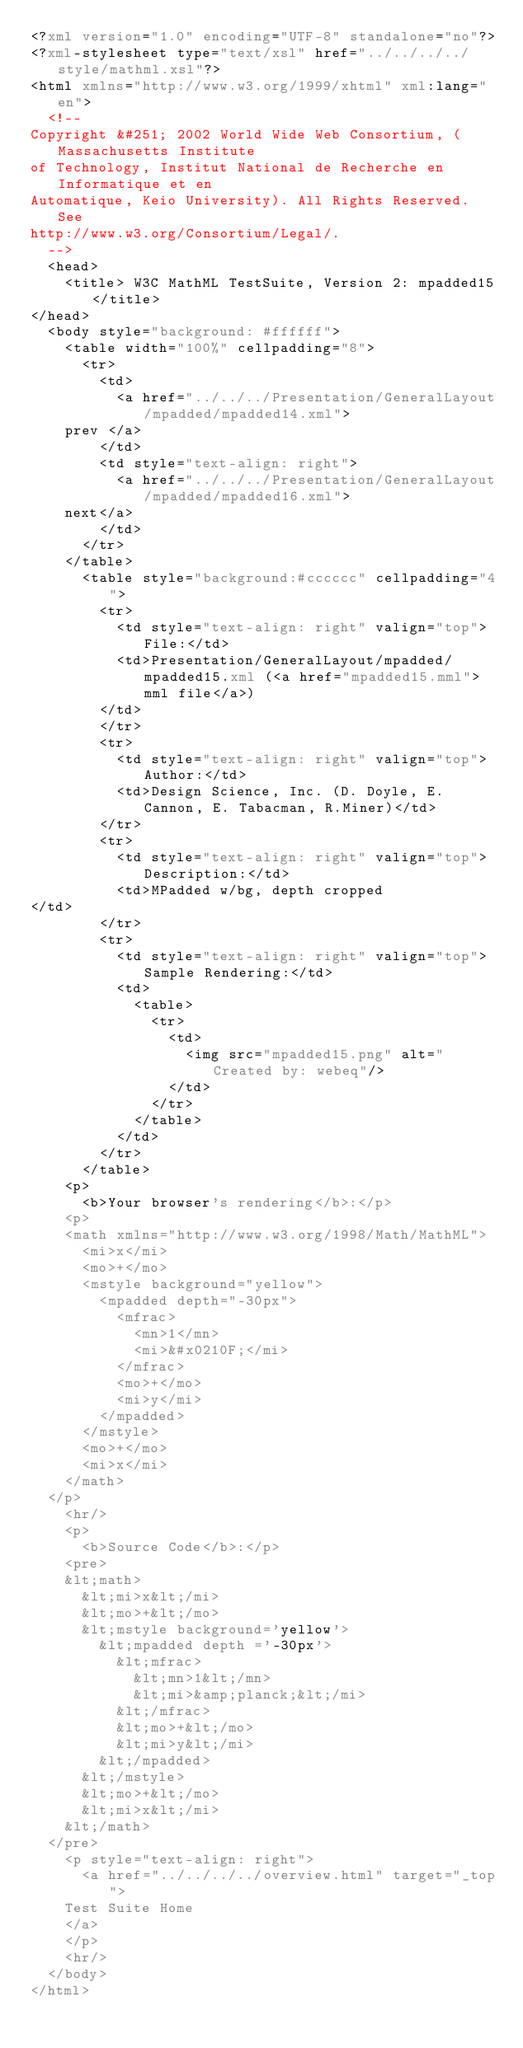<code> <loc_0><loc_0><loc_500><loc_500><_XML_><?xml version="1.0" encoding="UTF-8" standalone="no"?>
<?xml-stylesheet type="text/xsl" href="../../../../style/mathml.xsl"?>
<html xmlns="http://www.w3.org/1999/xhtml" xml:lang="en">
  <!--
Copyright &#251; 2002 World Wide Web Consortium, (Massachusetts Institute
of Technology, Institut National de Recherche en Informatique et en
Automatique, Keio University). All Rights Reserved. See
http://www.w3.org/Consortium/Legal/.
  -->
  <head>
    <title> W3C MathML TestSuite, Version 2: mpadded15</title>
</head>
  <body style="background: #ffffff">
    <table width="100%" cellpadding="8">
      <tr>
        <td>
          <a href="../../../Presentation/GeneralLayout/mpadded/mpadded14.xml">
    prev </a>
        </td>
        <td style="text-align: right">
          <a href="../../../Presentation/GeneralLayout/mpadded/mpadded16.xml">
    next</a>
        </td>
      </tr>
    </table>
      <table style="background:#cccccc" cellpadding="4">
        <tr>
          <td style="text-align: right" valign="top">File:</td>
          <td>Presentation/GeneralLayout/mpadded/mpadded15.xml (<a href="mpadded15.mml">mml file</a>)
        </td>
        </tr>
        <tr>
          <td style="text-align: right" valign="top">Author:</td>
          <td>Design Science, Inc. (D. Doyle, E. Cannon, E. Tabacman, R.Miner)</td>
        </tr>
        <tr>
          <td style="text-align: right" valign="top">Description:</td>
          <td>MPadded w/bg, depth cropped
</td>
        </tr>
        <tr>
          <td style="text-align: right" valign="top">Sample Rendering:</td>
          <td>
            <table>
              <tr>
                <td>
                  <img src="mpadded15.png" alt="Created by: webeq"/>
                </td>
              </tr>
            </table>
          </td>
        </tr>
      </table>
    <p>
      <b>Your browser's rendering</b>:</p>
    <p>
    <math xmlns="http://www.w3.org/1998/Math/MathML"> 
      <mi>x</mi> 
      <mo>+</mo> 
      <mstyle background="yellow"> 
        <mpadded depth="-30px"> 
          <mfrac> 
            <mn>1</mn> 
            <mi>&#x0210F;</mi> 
          </mfrac> 
          <mo>+</mo> 
          <mi>y</mi> 
        </mpadded> 
      </mstyle> 
      <mo>+</mo> 
      <mi>x</mi> 
    </math>
  </p>
    <hr/>
    <p>
      <b>Source Code</b>:</p>
    <pre>
    &lt;math> 
      &lt;mi>x&lt;/mi> 
      &lt;mo>+&lt;/mo> 
      &lt;mstyle background='yellow'> 
        &lt;mpadded depth ='-30px'> 
          &lt;mfrac> 
            &lt;mn>1&lt;/mn> 
            &lt;mi>&amp;planck;&lt;/mi> 
          &lt;/mfrac> 
          &lt;mo>+&lt;/mo> 
          &lt;mi>y&lt;/mi> 
        &lt;/mpadded> 
      &lt;/mstyle> 
      &lt;mo>+&lt;/mo> 
      &lt;mi>x&lt;/mi> 
    &lt;/math>
  </pre>
    <p style="text-align: right">
      <a href="../../../../overview.html" target="_top">
	Test Suite Home
	</a>
    </p>
    <hr/>
  </body>
</html>
</code> 